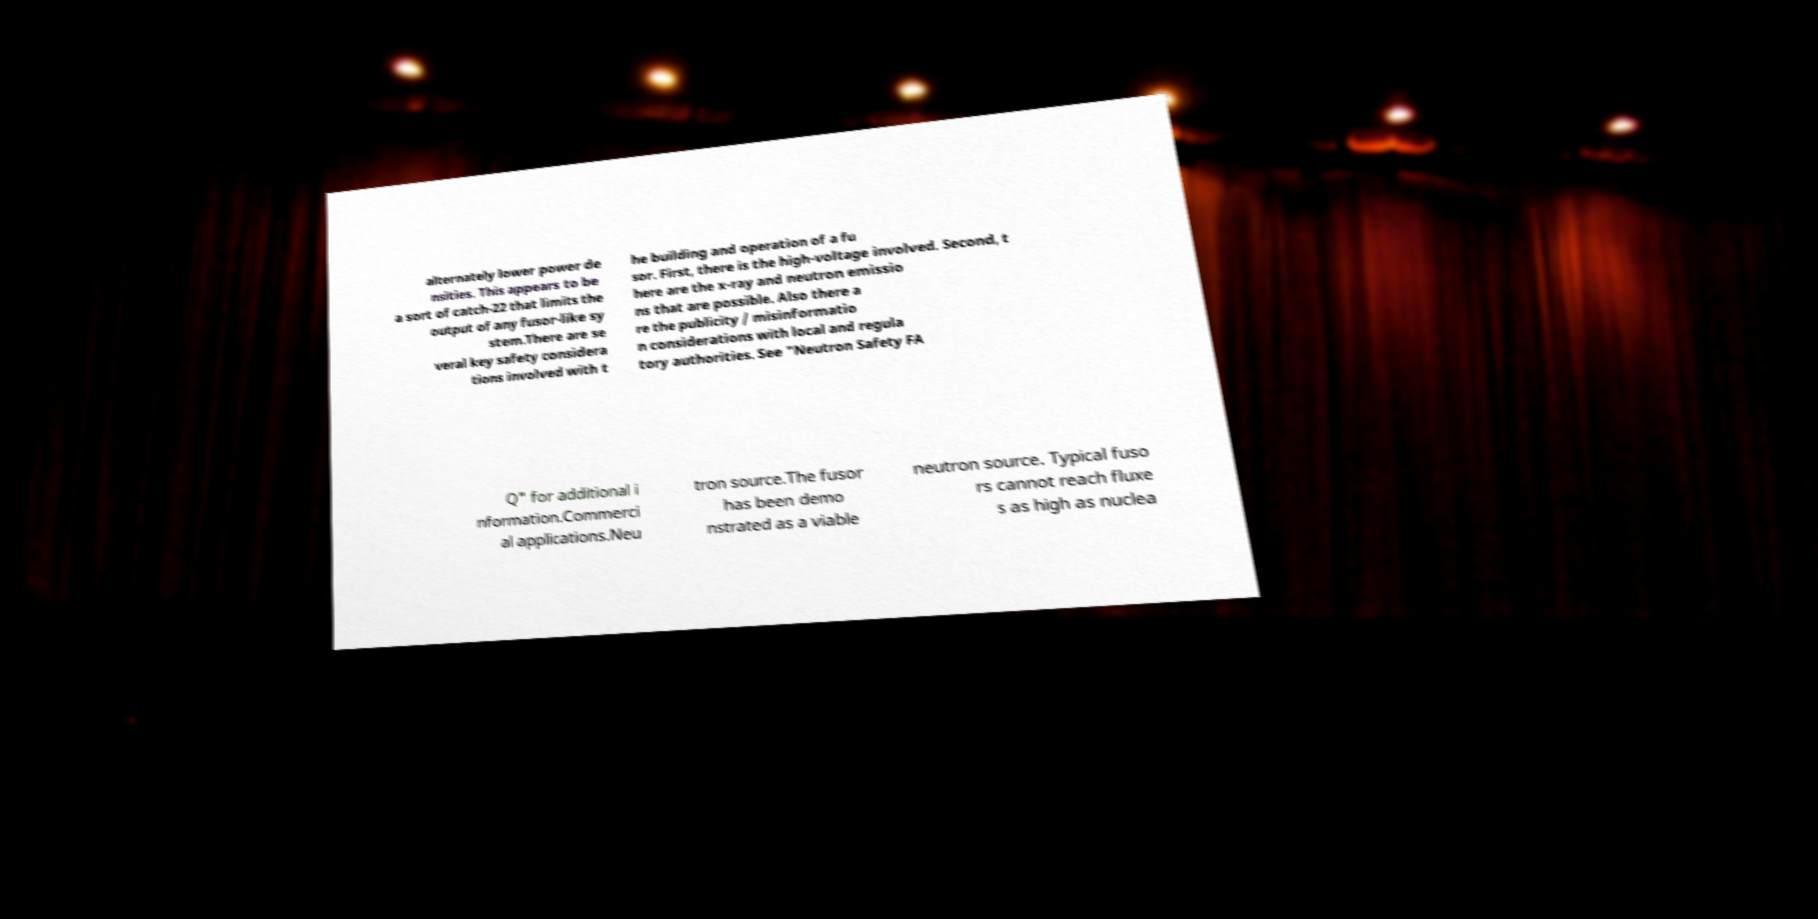Please read and relay the text visible in this image. What does it say? alternately lower power de nsities. This appears to be a sort of catch-22 that limits the output of any fusor-like sy stem.There are se veral key safety considera tions involved with t he building and operation of a fu sor. First, there is the high-voltage involved. Second, t here are the x-ray and neutron emissio ns that are possible. Also there a re the publicity / misinformatio n considerations with local and regula tory authorities. See "Neutron Safety FA Q" for additional i nformation.Commerci al applications.Neu tron source.The fusor has been demo nstrated as a viable neutron source. Typical fuso rs cannot reach fluxe s as high as nuclea 